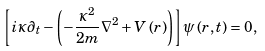<formula> <loc_0><loc_0><loc_500><loc_500>\left [ i \kappa \partial _ { t } - \left ( - \frac { \kappa ^ { 2 } } { 2 m } \nabla ^ { 2 } + V \left ( r \right ) \right ) \right ] \psi \left ( r , t \right ) = 0 ,</formula> 